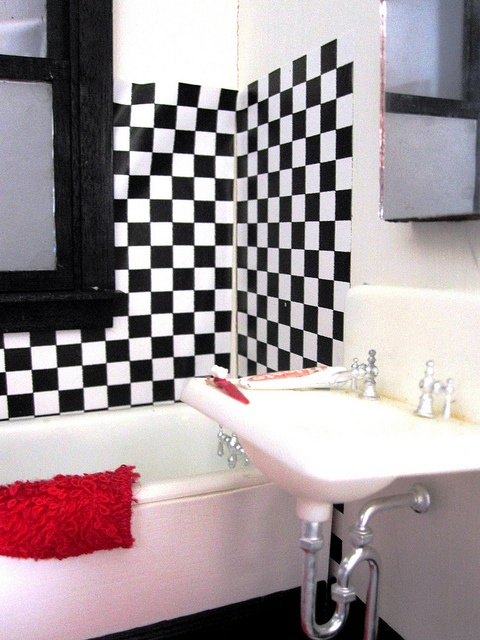Describe the objects in this image and their specific colors. I can see sink in lavender, white, pink, darkgray, and tan tones and toothbrush in lavender, salmon, white, and brown tones in this image. 